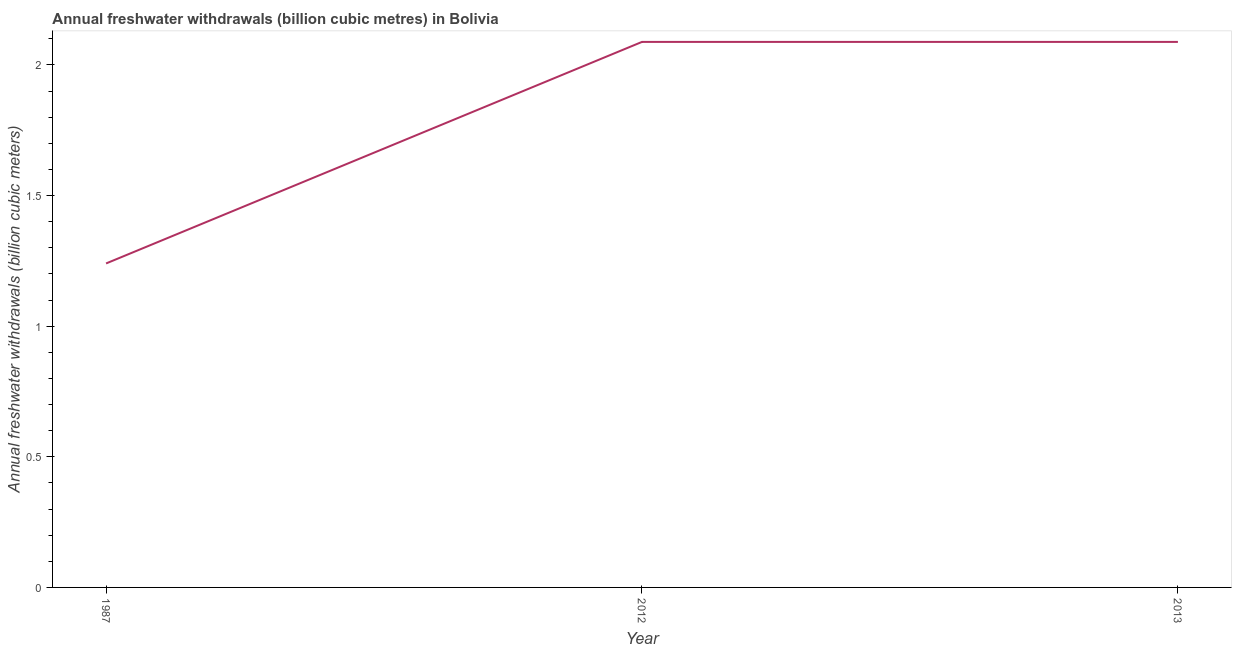What is the annual freshwater withdrawals in 2012?
Ensure brevity in your answer.  2.09. Across all years, what is the maximum annual freshwater withdrawals?
Give a very brief answer. 2.09. Across all years, what is the minimum annual freshwater withdrawals?
Make the answer very short. 1.24. In which year was the annual freshwater withdrawals maximum?
Your answer should be very brief. 2012. In which year was the annual freshwater withdrawals minimum?
Provide a short and direct response. 1987. What is the sum of the annual freshwater withdrawals?
Offer a very short reply. 5.42. What is the difference between the annual freshwater withdrawals in 1987 and 2012?
Your answer should be compact. -0.85. What is the average annual freshwater withdrawals per year?
Provide a short and direct response. 1.81. What is the median annual freshwater withdrawals?
Your answer should be compact. 2.09. What is the ratio of the annual freshwater withdrawals in 1987 to that in 2012?
Provide a short and direct response. 0.59. Is the annual freshwater withdrawals in 1987 less than that in 2012?
Give a very brief answer. Yes. Is the difference between the annual freshwater withdrawals in 1987 and 2013 greater than the difference between any two years?
Provide a succinct answer. Yes. What is the difference between the highest and the lowest annual freshwater withdrawals?
Your response must be concise. 0.85. In how many years, is the annual freshwater withdrawals greater than the average annual freshwater withdrawals taken over all years?
Ensure brevity in your answer.  2. Does the annual freshwater withdrawals monotonically increase over the years?
Make the answer very short. No. How many years are there in the graph?
Offer a terse response. 3. Are the values on the major ticks of Y-axis written in scientific E-notation?
Offer a very short reply. No. Does the graph contain any zero values?
Your response must be concise. No. What is the title of the graph?
Provide a succinct answer. Annual freshwater withdrawals (billion cubic metres) in Bolivia. What is the label or title of the Y-axis?
Your response must be concise. Annual freshwater withdrawals (billion cubic meters). What is the Annual freshwater withdrawals (billion cubic meters) in 1987?
Make the answer very short. 1.24. What is the Annual freshwater withdrawals (billion cubic meters) in 2012?
Keep it short and to the point. 2.09. What is the Annual freshwater withdrawals (billion cubic meters) of 2013?
Your answer should be compact. 2.09. What is the difference between the Annual freshwater withdrawals (billion cubic meters) in 1987 and 2012?
Make the answer very short. -0.85. What is the difference between the Annual freshwater withdrawals (billion cubic meters) in 1987 and 2013?
Offer a terse response. -0.85. What is the ratio of the Annual freshwater withdrawals (billion cubic meters) in 1987 to that in 2012?
Make the answer very short. 0.59. What is the ratio of the Annual freshwater withdrawals (billion cubic meters) in 1987 to that in 2013?
Provide a short and direct response. 0.59. 